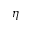Convert formula to latex. <formula><loc_0><loc_0><loc_500><loc_500>\eta</formula> 